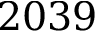<formula> <loc_0><loc_0><loc_500><loc_500>2 0 3 9</formula> 